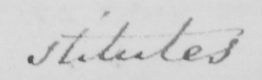Please provide the text content of this handwritten line. stitutes 